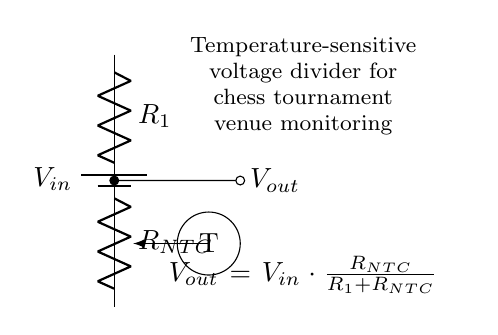What components are present in the circuit? The circuit consists of a battery, two resistors (R1 and NTC), and a temperature indicator. These components are connected in a specific configuration to form a voltage divider.
Answer: Battery, R1, NTC What is the purpose of the NTC resistor? The NTC (Negative Temperature Coefficient) resistor decreases its resistance with an increase in temperature, enabling the circuit to monitor temperature changes by affecting the output voltage.
Answer: Temperature monitoring What does Vout represent in the circuit? Vout is the output voltage obtained from the voltage divider, calculated based on the resistances R1 and RNTC and the input voltage Vin.
Answer: Output voltage How does temperature affect Vout? As the temperature increases, the resistance of the NTC decreases, which leads to a change in Vout according to the voltage divider formula; thus, higher temperatures correlate to lower Vout.
Answer: Decreases What is the voltage division equation used in this circuit? The voltage division equation given in the circuit is Vout = Vin multiplied by the ratio of RNTC over the sum of R1 and RNTC. This mathematically represents how the input voltage is divided among the resistors.
Answer: Vout = Vin * (RNTC / (R1 + RNTC)) What happens to Vout if R1 increases? If R1 increases while RNTC remains constant, Vout will decrease according to the voltage division principle, as a larger R1 causes a larger portion of Vin to appear across R1.
Answer: Decreases 